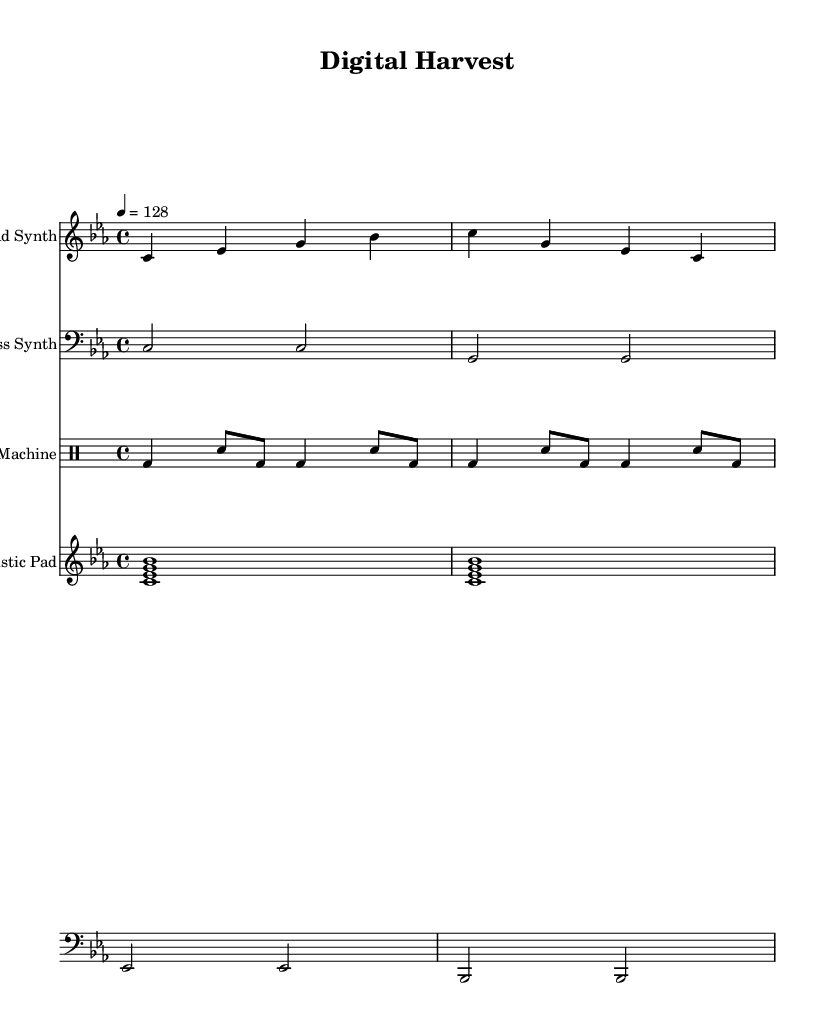What is the key signature of this music? The key signature of the music is indicated as C minor, which has three flats (B flat, E flat, and A flat). It can be identified in the initial part of the score where clef and key signature are marked.
Answer: C minor What is the time signature of this music? The time signature shown in the music is 4/4, which means there are four beats in a measure, and the quarter note gets one beat. This can be detected in the notated section where the time signature is explicitly stated.
Answer: 4/4 What is the tempo marking for this piece? The tempo marking is indicated in the score as 4 equals 128, meaning that there are 128 beats per minute, with the quarter note receiving the beat. This is found near the beginning of the score where the tempo is described.
Answer: 128 How many measures are in the lead synth part? The lead synth part has a total of two measures, which can be counted based on the notation provided in the staff for this instrument. Each measure in the part shows distinct rhythmic patterns.
Answer: 2 Which instrument has the bass clef? The instrument using the bass clef is the bass synth, which is indicated at the beginning of its staff where the clef is visually represented. This shows that it is designated to play lower register notes.
Answer: Bass Synth What rhythmic pattern is predominant in the drum machine? The predominant rhythmic pattern in the drum machine part consists of the combination of bass drums and snare drums that repeat, establishing a steady dance beat typical for tech-house music.
Answer: Bass and snare Which section contains the futuristic pad sound? The futuristic pad sound is located in its own separate staff also marked in the score, explicitly labeled as "Futuristic Pad," showing that this part contributes ambient textures to the overall sound.
Answer: Futuristic Pad 